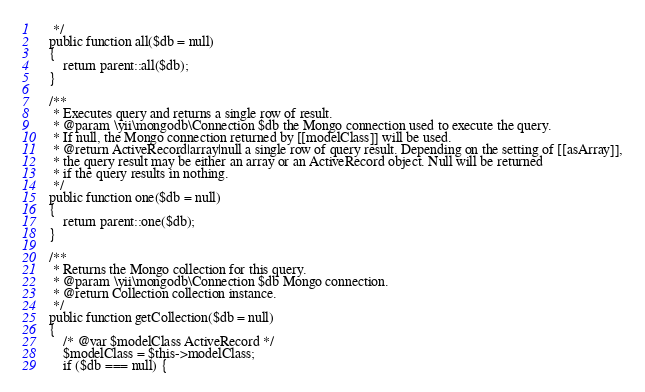Convert code to text. <code><loc_0><loc_0><loc_500><loc_500><_PHP_>     */
    public function all($db = null)
    {
        return parent::all($db);
    }

    /**
     * Executes query and returns a single row of result.
     * @param \yii\mongodb\Connection $db the Mongo connection used to execute the query.
     * If null, the Mongo connection returned by [[modelClass]] will be used.
     * @return ActiveRecord|array|null a single row of query result. Depending on the setting of [[asArray]],
     * the query result may be either an array or an ActiveRecord object. Null will be returned
     * if the query results in nothing.
     */
    public function one($db = null)
    {
        return parent::one($db);
    }

    /**
     * Returns the Mongo collection for this query.
     * @param \yii\mongodb\Connection $db Mongo connection.
     * @return Collection collection instance.
     */
    public function getCollection($db = null)
    {
        /* @var $modelClass ActiveRecord */
        $modelClass = $this->modelClass;
        if ($db === null) {</code> 